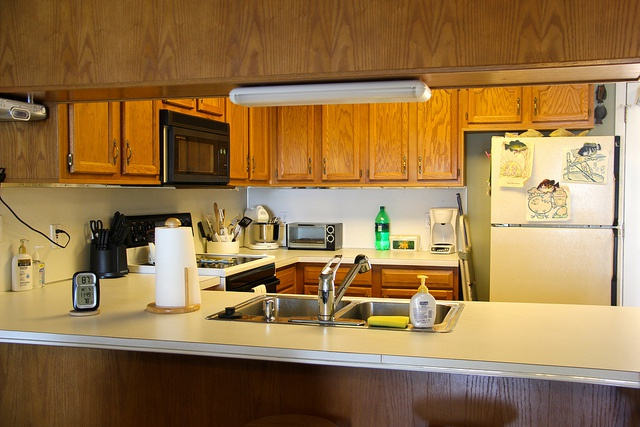Describe the objects in this image and their specific colors. I can see refrigerator in maroon, khaki, beige, and tan tones, sink in maroon, olive, gray, and black tones, microwave in maroon, black, and olive tones, oven in maroon, black, khaki, olive, and lightgray tones, and oven in maroon, darkgray, gray, and black tones in this image. 